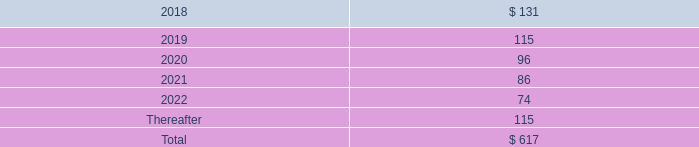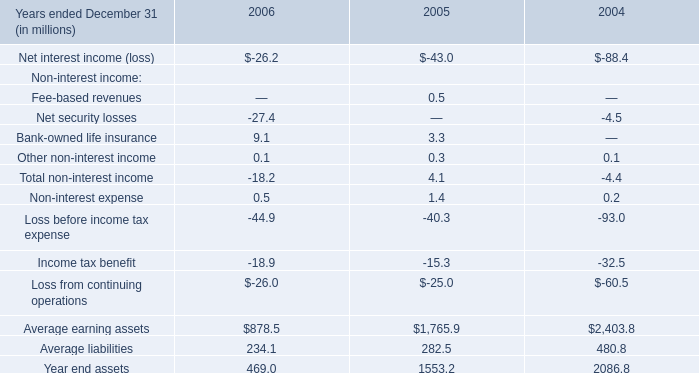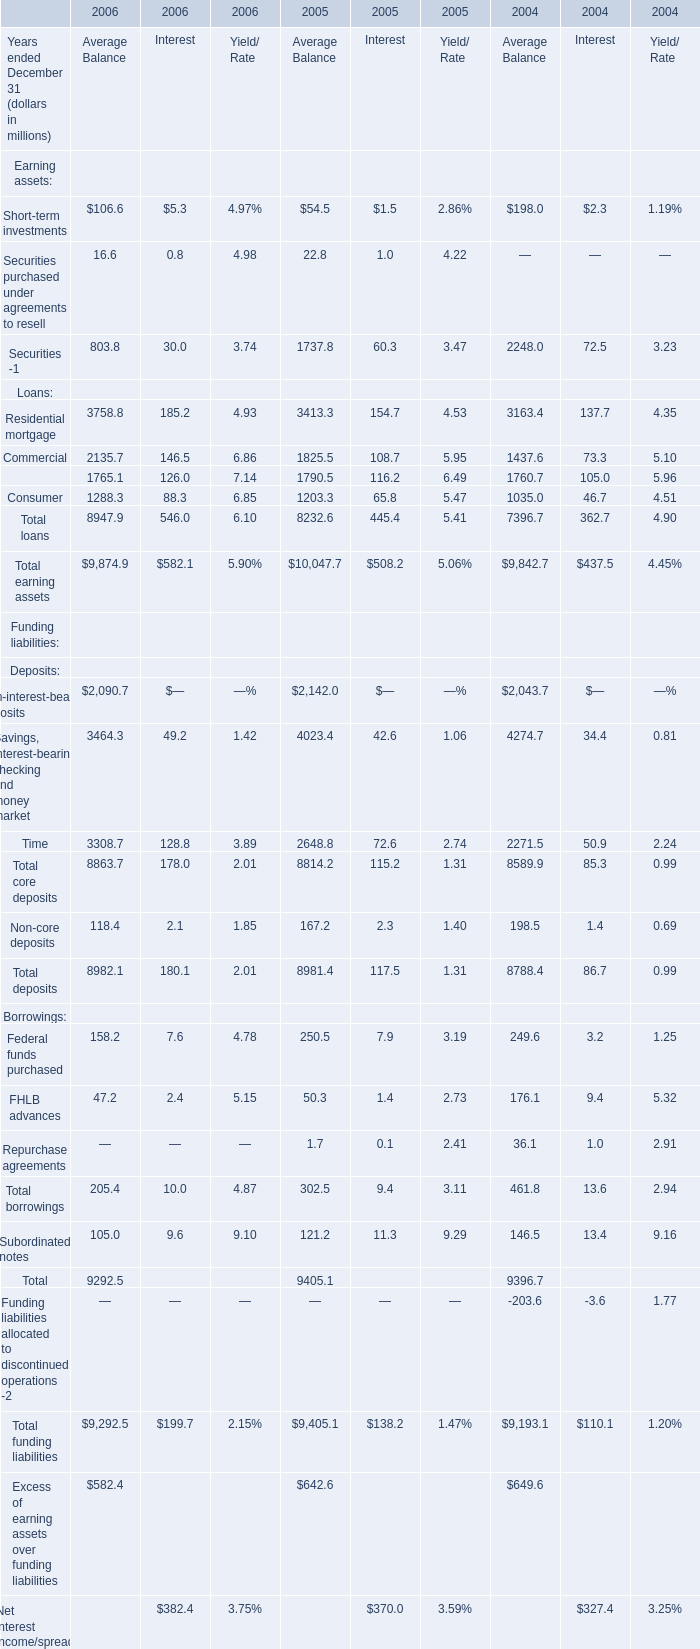what is the percentage change in the r&d expenses from 2016 to 2017? 
Computations: ((201 - 189) / 189)
Answer: 0.06349. 